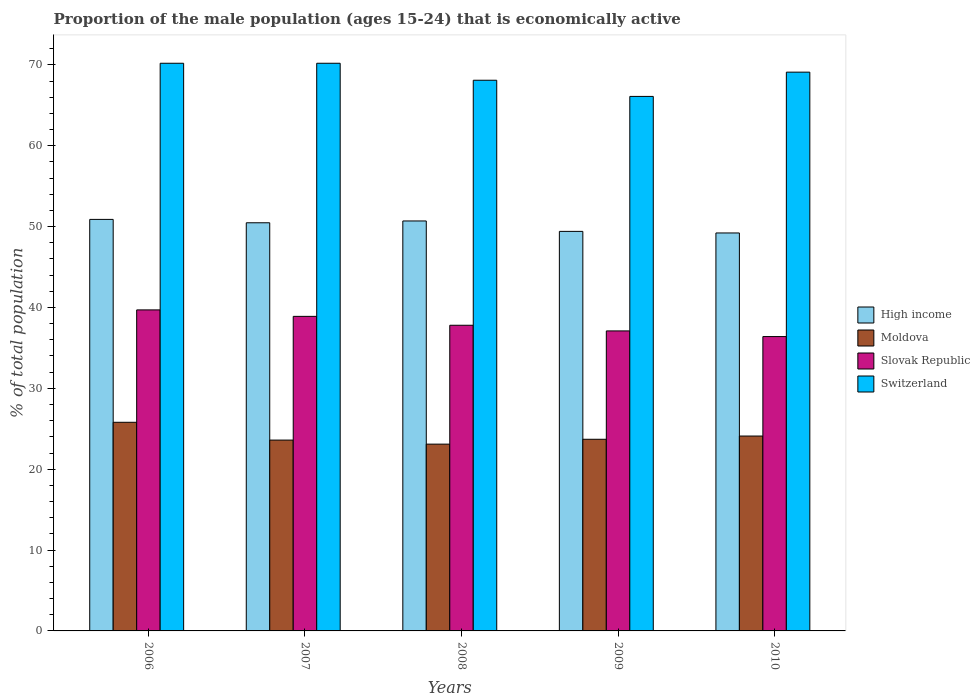How many different coloured bars are there?
Ensure brevity in your answer.  4. How many groups of bars are there?
Your answer should be very brief. 5. How many bars are there on the 3rd tick from the right?
Your answer should be compact. 4. What is the proportion of the male population that is economically active in Moldova in 2006?
Your response must be concise. 25.8. Across all years, what is the maximum proportion of the male population that is economically active in Slovak Republic?
Offer a terse response. 39.7. Across all years, what is the minimum proportion of the male population that is economically active in Slovak Republic?
Provide a short and direct response. 36.4. In which year was the proportion of the male population that is economically active in High income maximum?
Your answer should be compact. 2006. What is the total proportion of the male population that is economically active in Switzerland in the graph?
Provide a short and direct response. 343.7. What is the difference between the proportion of the male population that is economically active in Switzerland in 2006 and that in 2009?
Provide a short and direct response. 4.1. What is the difference between the proportion of the male population that is economically active in Slovak Republic in 2010 and the proportion of the male population that is economically active in Moldova in 2006?
Give a very brief answer. 10.6. What is the average proportion of the male population that is economically active in High income per year?
Provide a succinct answer. 50.14. In the year 2010, what is the difference between the proportion of the male population that is economically active in Switzerland and proportion of the male population that is economically active in High income?
Provide a succinct answer. 19.89. What is the ratio of the proportion of the male population that is economically active in Moldova in 2007 to that in 2009?
Your answer should be compact. 1. Is the difference between the proportion of the male population that is economically active in Switzerland in 2006 and 2009 greater than the difference between the proportion of the male population that is economically active in High income in 2006 and 2009?
Offer a very short reply. Yes. What is the difference between the highest and the second highest proportion of the male population that is economically active in Moldova?
Give a very brief answer. 1.7. What is the difference between the highest and the lowest proportion of the male population that is economically active in Switzerland?
Your answer should be very brief. 4.1. Is the sum of the proportion of the male population that is economically active in Slovak Republic in 2006 and 2007 greater than the maximum proportion of the male population that is economically active in Moldova across all years?
Provide a succinct answer. Yes. What does the 2nd bar from the left in 2009 represents?
Make the answer very short. Moldova. What does the 2nd bar from the right in 2009 represents?
Give a very brief answer. Slovak Republic. Is it the case that in every year, the sum of the proportion of the male population that is economically active in High income and proportion of the male population that is economically active in Slovak Republic is greater than the proportion of the male population that is economically active in Switzerland?
Offer a very short reply. Yes. Are all the bars in the graph horizontal?
Your response must be concise. No. Where does the legend appear in the graph?
Ensure brevity in your answer.  Center right. How many legend labels are there?
Offer a very short reply. 4. What is the title of the graph?
Your answer should be compact. Proportion of the male population (ages 15-24) that is economically active. Does "Arab World" appear as one of the legend labels in the graph?
Keep it short and to the point. No. What is the label or title of the X-axis?
Make the answer very short. Years. What is the label or title of the Y-axis?
Ensure brevity in your answer.  % of total population. What is the % of total population of High income in 2006?
Ensure brevity in your answer.  50.89. What is the % of total population in Moldova in 2006?
Make the answer very short. 25.8. What is the % of total population in Slovak Republic in 2006?
Your answer should be compact. 39.7. What is the % of total population of Switzerland in 2006?
Your response must be concise. 70.2. What is the % of total population of High income in 2007?
Make the answer very short. 50.47. What is the % of total population of Moldova in 2007?
Your answer should be compact. 23.6. What is the % of total population in Slovak Republic in 2007?
Offer a very short reply. 38.9. What is the % of total population in Switzerland in 2007?
Offer a very short reply. 70.2. What is the % of total population in High income in 2008?
Offer a very short reply. 50.7. What is the % of total population in Moldova in 2008?
Provide a succinct answer. 23.1. What is the % of total population of Slovak Republic in 2008?
Offer a terse response. 37.8. What is the % of total population of Switzerland in 2008?
Provide a succinct answer. 68.1. What is the % of total population in High income in 2009?
Offer a very short reply. 49.41. What is the % of total population of Moldova in 2009?
Ensure brevity in your answer.  23.7. What is the % of total population of Slovak Republic in 2009?
Give a very brief answer. 37.1. What is the % of total population in Switzerland in 2009?
Give a very brief answer. 66.1. What is the % of total population of High income in 2010?
Provide a succinct answer. 49.21. What is the % of total population of Moldova in 2010?
Provide a succinct answer. 24.1. What is the % of total population in Slovak Republic in 2010?
Your response must be concise. 36.4. What is the % of total population of Switzerland in 2010?
Your answer should be compact. 69.1. Across all years, what is the maximum % of total population of High income?
Offer a very short reply. 50.89. Across all years, what is the maximum % of total population of Moldova?
Provide a succinct answer. 25.8. Across all years, what is the maximum % of total population in Slovak Republic?
Make the answer very short. 39.7. Across all years, what is the maximum % of total population of Switzerland?
Give a very brief answer. 70.2. Across all years, what is the minimum % of total population of High income?
Your response must be concise. 49.21. Across all years, what is the minimum % of total population in Moldova?
Provide a succinct answer. 23.1. Across all years, what is the minimum % of total population of Slovak Republic?
Keep it short and to the point. 36.4. Across all years, what is the minimum % of total population of Switzerland?
Provide a short and direct response. 66.1. What is the total % of total population in High income in the graph?
Provide a short and direct response. 250.68. What is the total % of total population of Moldova in the graph?
Your answer should be compact. 120.3. What is the total % of total population of Slovak Republic in the graph?
Give a very brief answer. 189.9. What is the total % of total population of Switzerland in the graph?
Your response must be concise. 343.7. What is the difference between the % of total population in High income in 2006 and that in 2007?
Give a very brief answer. 0.42. What is the difference between the % of total population of Moldova in 2006 and that in 2007?
Keep it short and to the point. 2.2. What is the difference between the % of total population in Slovak Republic in 2006 and that in 2007?
Make the answer very short. 0.8. What is the difference between the % of total population in Switzerland in 2006 and that in 2007?
Keep it short and to the point. 0. What is the difference between the % of total population of High income in 2006 and that in 2008?
Provide a short and direct response. 0.19. What is the difference between the % of total population of Switzerland in 2006 and that in 2008?
Ensure brevity in your answer.  2.1. What is the difference between the % of total population of High income in 2006 and that in 2009?
Offer a very short reply. 1.48. What is the difference between the % of total population in Switzerland in 2006 and that in 2009?
Your answer should be compact. 4.1. What is the difference between the % of total population of High income in 2006 and that in 2010?
Your response must be concise. 1.68. What is the difference between the % of total population of Slovak Republic in 2006 and that in 2010?
Your answer should be compact. 3.3. What is the difference between the % of total population of High income in 2007 and that in 2008?
Your answer should be very brief. -0.22. What is the difference between the % of total population in High income in 2007 and that in 2009?
Make the answer very short. 1.06. What is the difference between the % of total population in Moldova in 2007 and that in 2009?
Give a very brief answer. -0.1. What is the difference between the % of total population in Slovak Republic in 2007 and that in 2009?
Offer a terse response. 1.8. What is the difference between the % of total population in Switzerland in 2007 and that in 2009?
Your response must be concise. 4.1. What is the difference between the % of total population of High income in 2007 and that in 2010?
Offer a very short reply. 1.26. What is the difference between the % of total population of Moldova in 2007 and that in 2010?
Ensure brevity in your answer.  -0.5. What is the difference between the % of total population of Switzerland in 2007 and that in 2010?
Keep it short and to the point. 1.1. What is the difference between the % of total population in High income in 2008 and that in 2009?
Give a very brief answer. 1.29. What is the difference between the % of total population in Slovak Republic in 2008 and that in 2009?
Keep it short and to the point. 0.7. What is the difference between the % of total population of Switzerland in 2008 and that in 2009?
Ensure brevity in your answer.  2. What is the difference between the % of total population in High income in 2008 and that in 2010?
Your answer should be very brief. 1.48. What is the difference between the % of total population of Slovak Republic in 2008 and that in 2010?
Offer a very short reply. 1.4. What is the difference between the % of total population of Switzerland in 2008 and that in 2010?
Give a very brief answer. -1. What is the difference between the % of total population in High income in 2009 and that in 2010?
Keep it short and to the point. 0.2. What is the difference between the % of total population of Slovak Republic in 2009 and that in 2010?
Make the answer very short. 0.7. What is the difference between the % of total population of High income in 2006 and the % of total population of Moldova in 2007?
Ensure brevity in your answer.  27.29. What is the difference between the % of total population of High income in 2006 and the % of total population of Slovak Republic in 2007?
Provide a succinct answer. 11.99. What is the difference between the % of total population in High income in 2006 and the % of total population in Switzerland in 2007?
Your answer should be very brief. -19.31. What is the difference between the % of total population of Moldova in 2006 and the % of total population of Switzerland in 2007?
Keep it short and to the point. -44.4. What is the difference between the % of total population in Slovak Republic in 2006 and the % of total population in Switzerland in 2007?
Ensure brevity in your answer.  -30.5. What is the difference between the % of total population of High income in 2006 and the % of total population of Moldova in 2008?
Make the answer very short. 27.79. What is the difference between the % of total population of High income in 2006 and the % of total population of Slovak Republic in 2008?
Your answer should be very brief. 13.09. What is the difference between the % of total population in High income in 2006 and the % of total population in Switzerland in 2008?
Provide a short and direct response. -17.21. What is the difference between the % of total population of Moldova in 2006 and the % of total population of Slovak Republic in 2008?
Make the answer very short. -12. What is the difference between the % of total population of Moldova in 2006 and the % of total population of Switzerland in 2008?
Make the answer very short. -42.3. What is the difference between the % of total population in Slovak Republic in 2006 and the % of total population in Switzerland in 2008?
Offer a terse response. -28.4. What is the difference between the % of total population of High income in 2006 and the % of total population of Moldova in 2009?
Offer a terse response. 27.19. What is the difference between the % of total population of High income in 2006 and the % of total population of Slovak Republic in 2009?
Your answer should be very brief. 13.79. What is the difference between the % of total population of High income in 2006 and the % of total population of Switzerland in 2009?
Ensure brevity in your answer.  -15.21. What is the difference between the % of total population of Moldova in 2006 and the % of total population of Slovak Republic in 2009?
Give a very brief answer. -11.3. What is the difference between the % of total population of Moldova in 2006 and the % of total population of Switzerland in 2009?
Offer a terse response. -40.3. What is the difference between the % of total population in Slovak Republic in 2006 and the % of total population in Switzerland in 2009?
Your answer should be very brief. -26.4. What is the difference between the % of total population of High income in 2006 and the % of total population of Moldova in 2010?
Provide a succinct answer. 26.79. What is the difference between the % of total population in High income in 2006 and the % of total population in Slovak Republic in 2010?
Provide a short and direct response. 14.49. What is the difference between the % of total population in High income in 2006 and the % of total population in Switzerland in 2010?
Offer a very short reply. -18.21. What is the difference between the % of total population of Moldova in 2006 and the % of total population of Slovak Republic in 2010?
Give a very brief answer. -10.6. What is the difference between the % of total population in Moldova in 2006 and the % of total population in Switzerland in 2010?
Offer a very short reply. -43.3. What is the difference between the % of total population of Slovak Republic in 2006 and the % of total population of Switzerland in 2010?
Ensure brevity in your answer.  -29.4. What is the difference between the % of total population in High income in 2007 and the % of total population in Moldova in 2008?
Offer a very short reply. 27.37. What is the difference between the % of total population in High income in 2007 and the % of total population in Slovak Republic in 2008?
Offer a very short reply. 12.67. What is the difference between the % of total population in High income in 2007 and the % of total population in Switzerland in 2008?
Your response must be concise. -17.63. What is the difference between the % of total population in Moldova in 2007 and the % of total population in Switzerland in 2008?
Give a very brief answer. -44.5. What is the difference between the % of total population in Slovak Republic in 2007 and the % of total population in Switzerland in 2008?
Keep it short and to the point. -29.2. What is the difference between the % of total population of High income in 2007 and the % of total population of Moldova in 2009?
Keep it short and to the point. 26.77. What is the difference between the % of total population in High income in 2007 and the % of total population in Slovak Republic in 2009?
Provide a short and direct response. 13.37. What is the difference between the % of total population of High income in 2007 and the % of total population of Switzerland in 2009?
Your response must be concise. -15.63. What is the difference between the % of total population in Moldova in 2007 and the % of total population in Slovak Republic in 2009?
Offer a terse response. -13.5. What is the difference between the % of total population of Moldova in 2007 and the % of total population of Switzerland in 2009?
Provide a short and direct response. -42.5. What is the difference between the % of total population in Slovak Republic in 2007 and the % of total population in Switzerland in 2009?
Offer a terse response. -27.2. What is the difference between the % of total population of High income in 2007 and the % of total population of Moldova in 2010?
Give a very brief answer. 26.37. What is the difference between the % of total population of High income in 2007 and the % of total population of Slovak Republic in 2010?
Provide a succinct answer. 14.07. What is the difference between the % of total population in High income in 2007 and the % of total population in Switzerland in 2010?
Make the answer very short. -18.63. What is the difference between the % of total population of Moldova in 2007 and the % of total population of Switzerland in 2010?
Offer a terse response. -45.5. What is the difference between the % of total population in Slovak Republic in 2007 and the % of total population in Switzerland in 2010?
Provide a short and direct response. -30.2. What is the difference between the % of total population of High income in 2008 and the % of total population of Moldova in 2009?
Your answer should be very brief. 27. What is the difference between the % of total population in High income in 2008 and the % of total population in Slovak Republic in 2009?
Your answer should be very brief. 13.6. What is the difference between the % of total population in High income in 2008 and the % of total population in Switzerland in 2009?
Offer a terse response. -15.4. What is the difference between the % of total population in Moldova in 2008 and the % of total population in Switzerland in 2009?
Your response must be concise. -43. What is the difference between the % of total population of Slovak Republic in 2008 and the % of total population of Switzerland in 2009?
Your answer should be very brief. -28.3. What is the difference between the % of total population of High income in 2008 and the % of total population of Moldova in 2010?
Your answer should be very brief. 26.6. What is the difference between the % of total population of High income in 2008 and the % of total population of Slovak Republic in 2010?
Your response must be concise. 14.3. What is the difference between the % of total population of High income in 2008 and the % of total population of Switzerland in 2010?
Your answer should be compact. -18.4. What is the difference between the % of total population in Moldova in 2008 and the % of total population in Switzerland in 2010?
Your answer should be very brief. -46. What is the difference between the % of total population of Slovak Republic in 2008 and the % of total population of Switzerland in 2010?
Your answer should be very brief. -31.3. What is the difference between the % of total population of High income in 2009 and the % of total population of Moldova in 2010?
Your answer should be compact. 25.31. What is the difference between the % of total population of High income in 2009 and the % of total population of Slovak Republic in 2010?
Your answer should be very brief. 13.01. What is the difference between the % of total population in High income in 2009 and the % of total population in Switzerland in 2010?
Offer a terse response. -19.69. What is the difference between the % of total population in Moldova in 2009 and the % of total population in Slovak Republic in 2010?
Give a very brief answer. -12.7. What is the difference between the % of total population in Moldova in 2009 and the % of total population in Switzerland in 2010?
Offer a very short reply. -45.4. What is the difference between the % of total population of Slovak Republic in 2009 and the % of total population of Switzerland in 2010?
Ensure brevity in your answer.  -32. What is the average % of total population in High income per year?
Provide a short and direct response. 50.14. What is the average % of total population of Moldova per year?
Your answer should be very brief. 24.06. What is the average % of total population of Slovak Republic per year?
Give a very brief answer. 37.98. What is the average % of total population of Switzerland per year?
Ensure brevity in your answer.  68.74. In the year 2006, what is the difference between the % of total population of High income and % of total population of Moldova?
Your answer should be compact. 25.09. In the year 2006, what is the difference between the % of total population of High income and % of total population of Slovak Republic?
Make the answer very short. 11.19. In the year 2006, what is the difference between the % of total population in High income and % of total population in Switzerland?
Provide a succinct answer. -19.31. In the year 2006, what is the difference between the % of total population in Moldova and % of total population in Slovak Republic?
Your response must be concise. -13.9. In the year 2006, what is the difference between the % of total population in Moldova and % of total population in Switzerland?
Make the answer very short. -44.4. In the year 2006, what is the difference between the % of total population of Slovak Republic and % of total population of Switzerland?
Offer a very short reply. -30.5. In the year 2007, what is the difference between the % of total population of High income and % of total population of Moldova?
Provide a succinct answer. 26.87. In the year 2007, what is the difference between the % of total population of High income and % of total population of Slovak Republic?
Your answer should be compact. 11.57. In the year 2007, what is the difference between the % of total population in High income and % of total population in Switzerland?
Keep it short and to the point. -19.73. In the year 2007, what is the difference between the % of total population in Moldova and % of total population in Slovak Republic?
Offer a terse response. -15.3. In the year 2007, what is the difference between the % of total population in Moldova and % of total population in Switzerland?
Ensure brevity in your answer.  -46.6. In the year 2007, what is the difference between the % of total population of Slovak Republic and % of total population of Switzerland?
Provide a short and direct response. -31.3. In the year 2008, what is the difference between the % of total population of High income and % of total population of Moldova?
Make the answer very short. 27.6. In the year 2008, what is the difference between the % of total population in High income and % of total population in Slovak Republic?
Your answer should be compact. 12.9. In the year 2008, what is the difference between the % of total population of High income and % of total population of Switzerland?
Provide a short and direct response. -17.4. In the year 2008, what is the difference between the % of total population in Moldova and % of total population in Slovak Republic?
Offer a very short reply. -14.7. In the year 2008, what is the difference between the % of total population in Moldova and % of total population in Switzerland?
Give a very brief answer. -45. In the year 2008, what is the difference between the % of total population of Slovak Republic and % of total population of Switzerland?
Make the answer very short. -30.3. In the year 2009, what is the difference between the % of total population in High income and % of total population in Moldova?
Keep it short and to the point. 25.71. In the year 2009, what is the difference between the % of total population of High income and % of total population of Slovak Republic?
Make the answer very short. 12.31. In the year 2009, what is the difference between the % of total population in High income and % of total population in Switzerland?
Keep it short and to the point. -16.69. In the year 2009, what is the difference between the % of total population of Moldova and % of total population of Slovak Republic?
Give a very brief answer. -13.4. In the year 2009, what is the difference between the % of total population in Moldova and % of total population in Switzerland?
Offer a very short reply. -42.4. In the year 2010, what is the difference between the % of total population in High income and % of total population in Moldova?
Offer a terse response. 25.11. In the year 2010, what is the difference between the % of total population of High income and % of total population of Slovak Republic?
Give a very brief answer. 12.81. In the year 2010, what is the difference between the % of total population of High income and % of total population of Switzerland?
Keep it short and to the point. -19.89. In the year 2010, what is the difference between the % of total population of Moldova and % of total population of Slovak Republic?
Your response must be concise. -12.3. In the year 2010, what is the difference between the % of total population in Moldova and % of total population in Switzerland?
Make the answer very short. -45. In the year 2010, what is the difference between the % of total population of Slovak Republic and % of total population of Switzerland?
Make the answer very short. -32.7. What is the ratio of the % of total population of High income in 2006 to that in 2007?
Your answer should be compact. 1.01. What is the ratio of the % of total population in Moldova in 2006 to that in 2007?
Your answer should be compact. 1.09. What is the ratio of the % of total population in Slovak Republic in 2006 to that in 2007?
Your answer should be compact. 1.02. What is the ratio of the % of total population in Switzerland in 2006 to that in 2007?
Your response must be concise. 1. What is the ratio of the % of total population of Moldova in 2006 to that in 2008?
Your answer should be very brief. 1.12. What is the ratio of the % of total population of Slovak Republic in 2006 to that in 2008?
Provide a short and direct response. 1.05. What is the ratio of the % of total population of Switzerland in 2006 to that in 2008?
Your answer should be very brief. 1.03. What is the ratio of the % of total population in Moldova in 2006 to that in 2009?
Your answer should be compact. 1.09. What is the ratio of the % of total population of Slovak Republic in 2006 to that in 2009?
Offer a very short reply. 1.07. What is the ratio of the % of total population in Switzerland in 2006 to that in 2009?
Your response must be concise. 1.06. What is the ratio of the % of total population in High income in 2006 to that in 2010?
Keep it short and to the point. 1.03. What is the ratio of the % of total population of Moldova in 2006 to that in 2010?
Provide a succinct answer. 1.07. What is the ratio of the % of total population of Slovak Republic in 2006 to that in 2010?
Your response must be concise. 1.09. What is the ratio of the % of total population of Switzerland in 2006 to that in 2010?
Your answer should be very brief. 1.02. What is the ratio of the % of total population in Moldova in 2007 to that in 2008?
Your response must be concise. 1.02. What is the ratio of the % of total population of Slovak Republic in 2007 to that in 2008?
Keep it short and to the point. 1.03. What is the ratio of the % of total population in Switzerland in 2007 to that in 2008?
Your answer should be compact. 1.03. What is the ratio of the % of total population in High income in 2007 to that in 2009?
Your answer should be compact. 1.02. What is the ratio of the % of total population in Moldova in 2007 to that in 2009?
Give a very brief answer. 1. What is the ratio of the % of total population in Slovak Republic in 2007 to that in 2009?
Keep it short and to the point. 1.05. What is the ratio of the % of total population in Switzerland in 2007 to that in 2009?
Offer a very short reply. 1.06. What is the ratio of the % of total population of High income in 2007 to that in 2010?
Give a very brief answer. 1.03. What is the ratio of the % of total population in Moldova in 2007 to that in 2010?
Your answer should be very brief. 0.98. What is the ratio of the % of total population in Slovak Republic in 2007 to that in 2010?
Keep it short and to the point. 1.07. What is the ratio of the % of total population in Switzerland in 2007 to that in 2010?
Your response must be concise. 1.02. What is the ratio of the % of total population of High income in 2008 to that in 2009?
Your answer should be very brief. 1.03. What is the ratio of the % of total population of Moldova in 2008 to that in 2009?
Ensure brevity in your answer.  0.97. What is the ratio of the % of total population in Slovak Republic in 2008 to that in 2009?
Keep it short and to the point. 1.02. What is the ratio of the % of total population in Switzerland in 2008 to that in 2009?
Make the answer very short. 1.03. What is the ratio of the % of total population of High income in 2008 to that in 2010?
Ensure brevity in your answer.  1.03. What is the ratio of the % of total population in Moldova in 2008 to that in 2010?
Provide a succinct answer. 0.96. What is the ratio of the % of total population in Switzerland in 2008 to that in 2010?
Your response must be concise. 0.99. What is the ratio of the % of total population in High income in 2009 to that in 2010?
Make the answer very short. 1. What is the ratio of the % of total population of Moldova in 2009 to that in 2010?
Provide a short and direct response. 0.98. What is the ratio of the % of total population in Slovak Republic in 2009 to that in 2010?
Provide a short and direct response. 1.02. What is the ratio of the % of total population in Switzerland in 2009 to that in 2010?
Make the answer very short. 0.96. What is the difference between the highest and the second highest % of total population of High income?
Offer a terse response. 0.19. What is the difference between the highest and the second highest % of total population of Moldova?
Keep it short and to the point. 1.7. What is the difference between the highest and the second highest % of total population in Slovak Republic?
Your answer should be compact. 0.8. What is the difference between the highest and the lowest % of total population of High income?
Ensure brevity in your answer.  1.68. What is the difference between the highest and the lowest % of total population in Slovak Republic?
Make the answer very short. 3.3. 